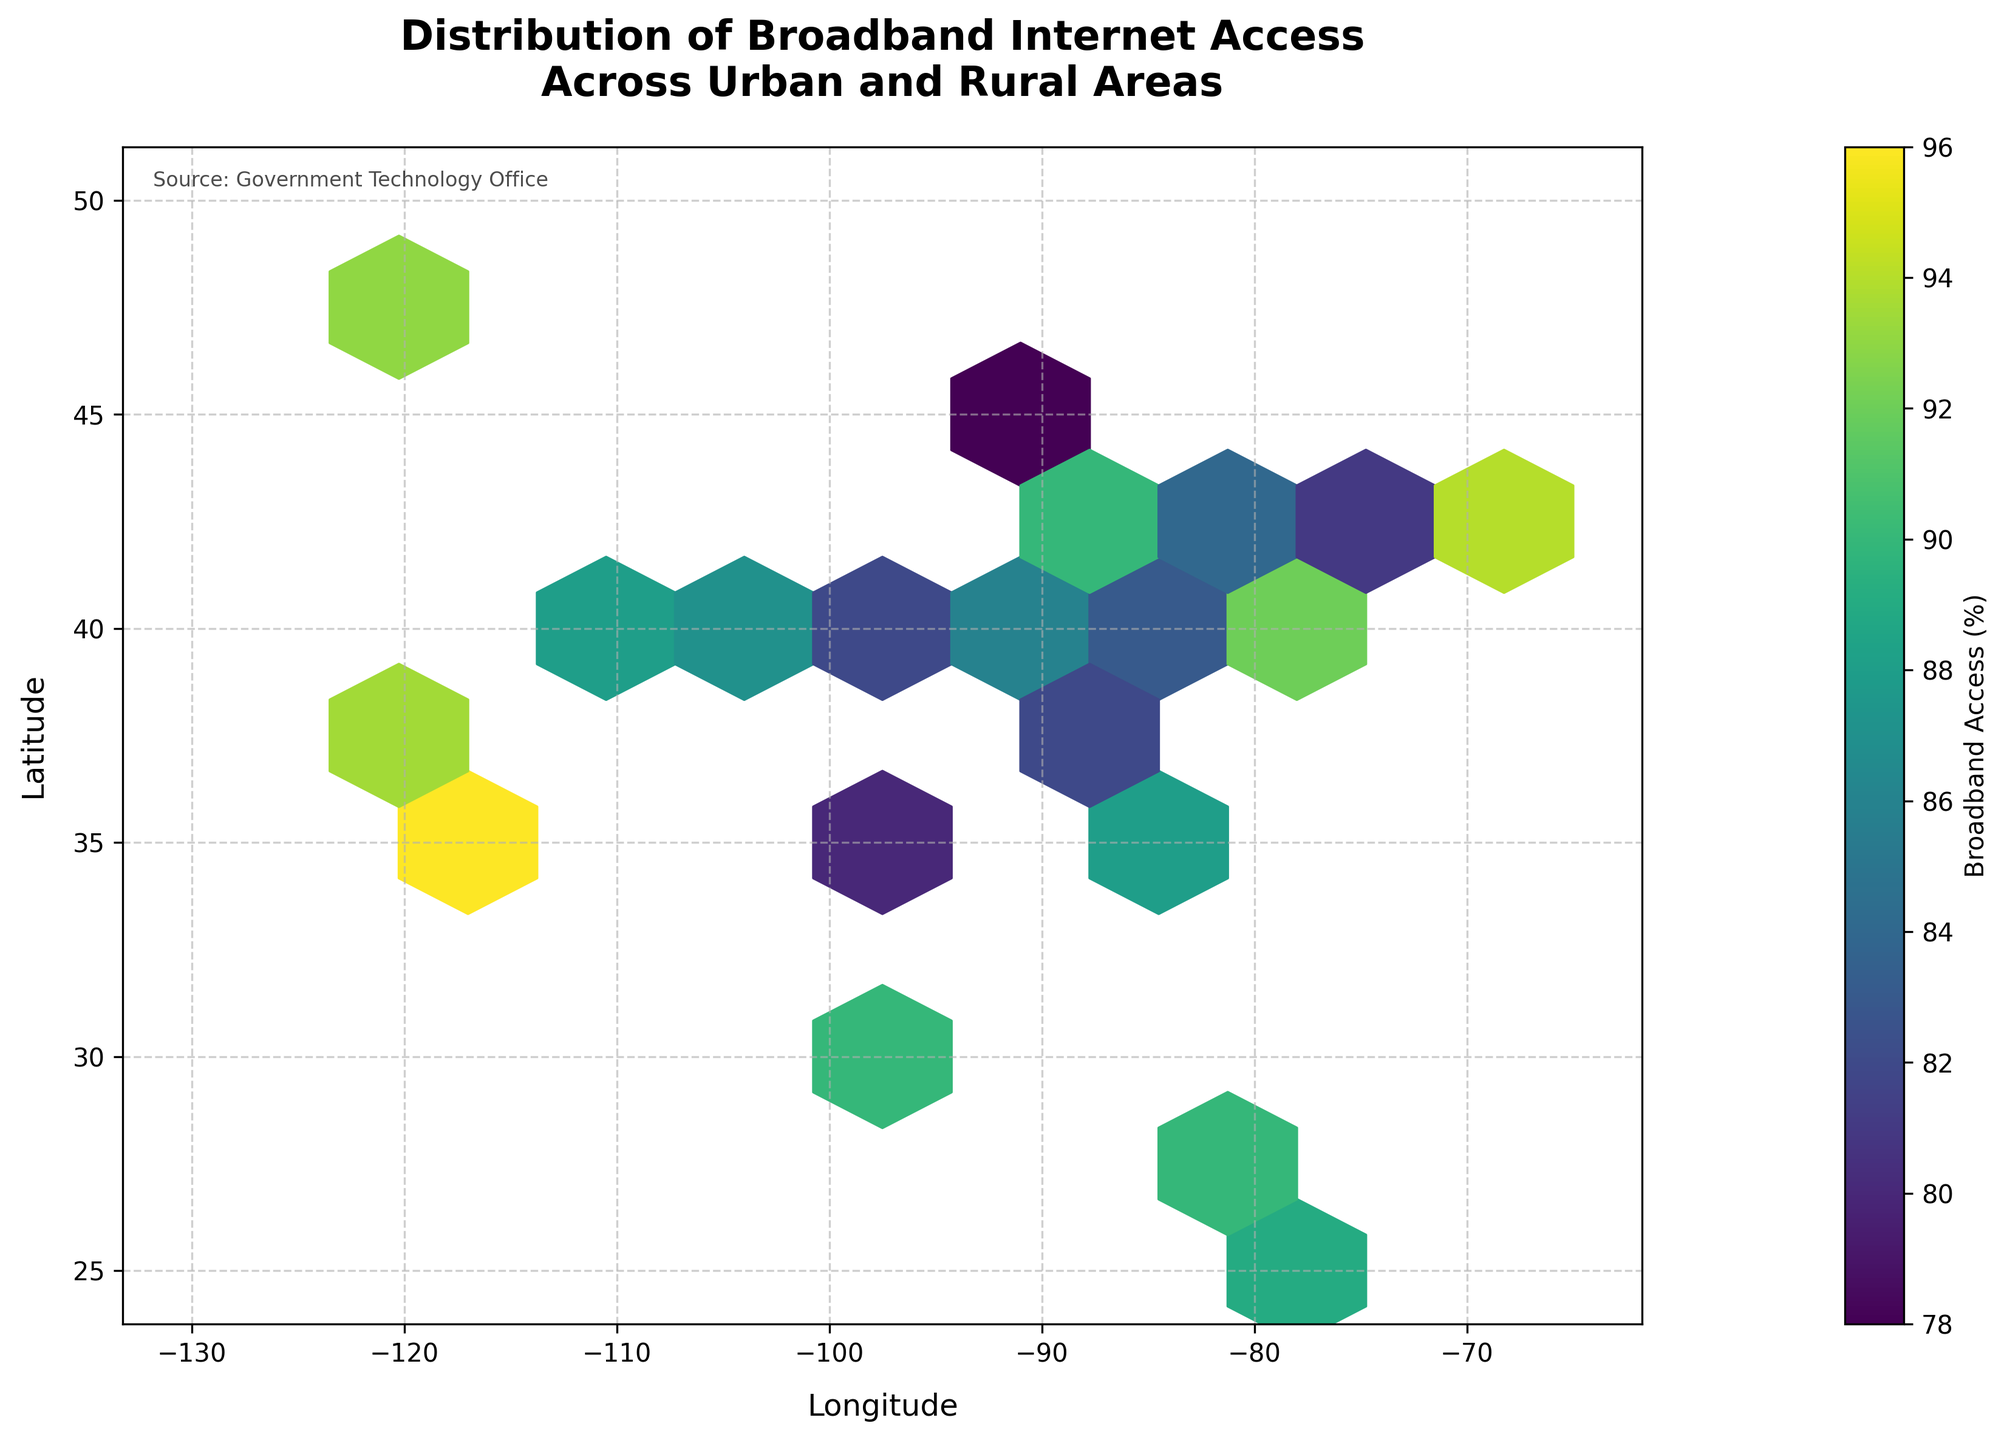What is the title of the figure? The title is located at the top of the figure, and it clearly states what the figure is about.
Answer: Distribution of Broadband Internet Access Across Urban and Rural Areas What are the units used on the color bar? The units on the color bar are indicated by its label, which is placed next to the color bar itself.
Answer: Broadband Access (%) What are the ranges for the x-axis and y-axis? The ranges for the x-axis and y-axis can be determined from the axis labels and tick marks. The x-axis ranges from -130 to -65, and the y-axis ranges from 25 to 50.
Answer: x-axis: -130 to -65, y-axis: 25 to 50 Which color represents the highest broadband access percentage? The color representing the highest broadband access percentage is indicated by the color bar; it's converted from a darker shade to a lighter one for higher values.
Answer: Light yellow Which region shows the highest broadband access according to the plot? By looking at the color intensity within the hexagonal bins and identifying the region with the lightest color, we determine the highest broadband access.
Answer: Western coastal areas How does broadband access in the central region compare to the eastern coastal region? By observing the color intensity in the central region and contrasting it with the eastern coastal region, we estimate the relative broadband access. The central region typically shows darker colors compared to the eastern coastal region, indicating lower broadband access.
Answer: Lower in the central region What is the color of areas with the lowest broadband access percentage? The areas with the lowest broadband access are represented by the color at the lowest end of the color bar, which is usually the darkest color.
Answer: Dark purple What visible pattern can we observe regarding broadband access in urban vs. rural areas? By analyzing the concentration of light and dark colors in different geographic areas, we can identify patterns. Urban areas, typically along the coasts and major cities, show lighter colors indicating higher access, while rural areas, particularly in the central region, show darker colors indicating lower access.
Answer: Higher in urban areas, lower in rural areas What is the significance of the hexagonal bin size, and how does it affect the plot? The hexagonal bin size impacts the granularity of data representation; smaller bins provide more detailed insights, whereas larger bins offer a more generalized view. In this plot, the chosen bin size balances detail with readability.
Answer: It affects the level of detail and readability 